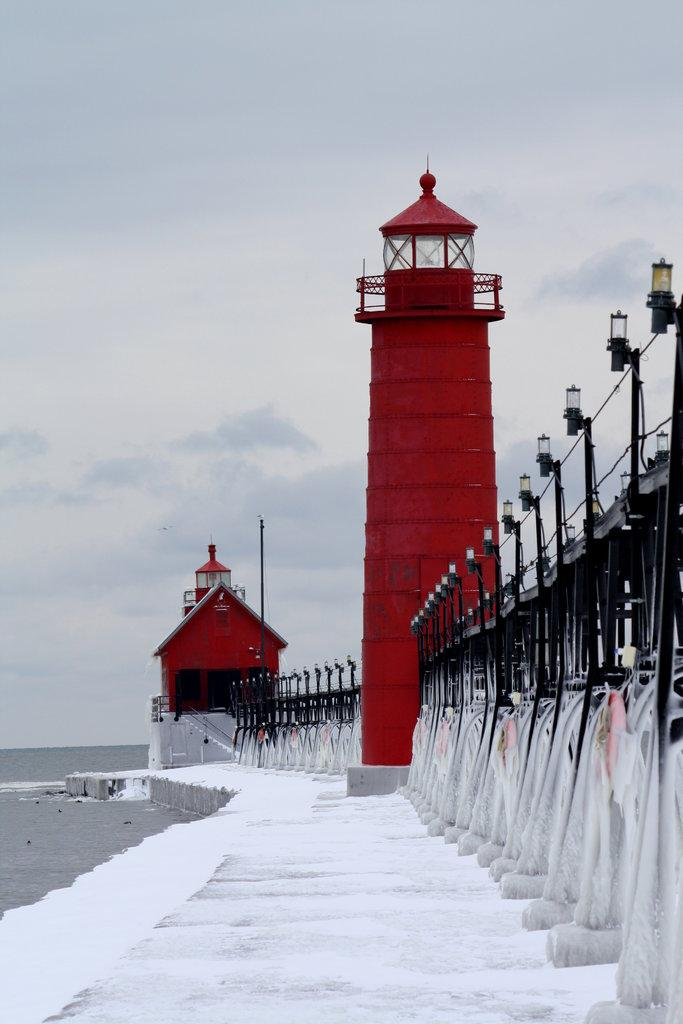What is the main structure in the image? There is a tower in the image. Are there any other buildings or structures in the image? Yes, there is a small house in the image. What can be seen illuminated in the image? There are lights visible in the image. What natural element is present in the image? There is water visible in the image. How would you describe the weather in the image? The sky appears to be cloudy in the image. What type of wool is being used to create the feeling of self in the image? There is no wool or reference to feelings or self in the image; it features a tower, a small house, lights, water, and a cloudy sky. 